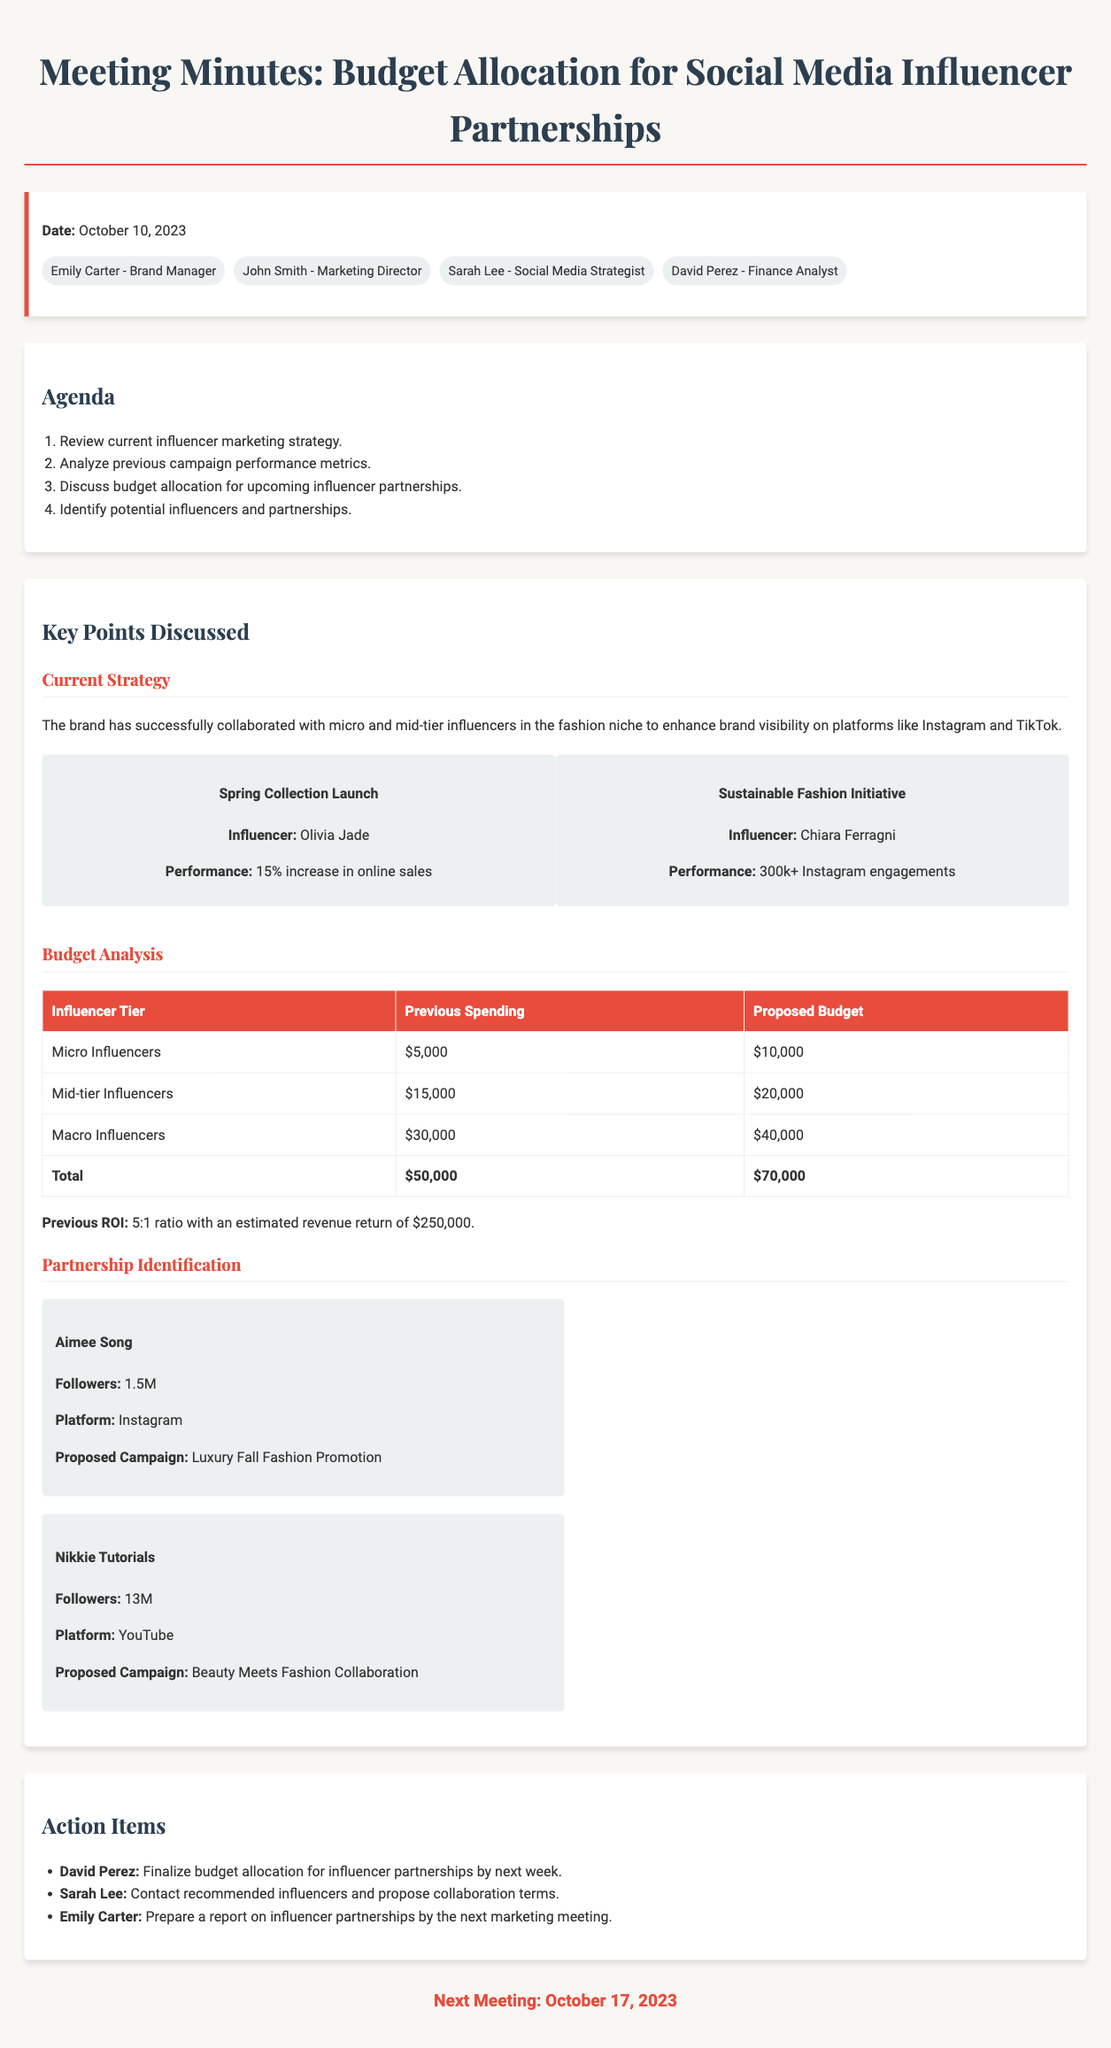What is the date of the meeting? The date of the meeting is listed at the top of the document as October 10, 2023.
Answer: October 10, 2023 Who proposed the Luxury Fall Fashion Promotion? The influencer Aimee Song is associated with the proposed campaign for Luxury Fall Fashion Promotion in the document.
Answer: Aimee Song What is the proposed budget for macro influencers? The document specifies the proposed budget for macro influencers is listed in the budget table.
Answer: $40,000 What was the previous spending on micro influencers? The document shows the previous spending for micro influencers outlined in the budget analysis section.
Answer: $5,000 How many followers does Nikkie Tutorials have? The document provides details about Nikkie Tutorials, including their follower count in the influencer recommendations.
Answer: 13M What ratio did the previous campaigns achieve for return on investment? The document indicates the previous ROI in the budget analysis section.
Answer: 5:1 What is the responsibility of David Perez as an action item? The action items section specifies David Perez's task related to budget allocation.
Answer: Finalize budget allocation What is the next meeting date? The next meeting date is clearly stated at the bottom of the document.
Answer: October 17, 2023 What type of influencers has the brand previously collaborated with? The current strategy discussed in the document mentions collaborating with micro and mid-tier influencers.
Answer: Micro and mid-tier influencers 